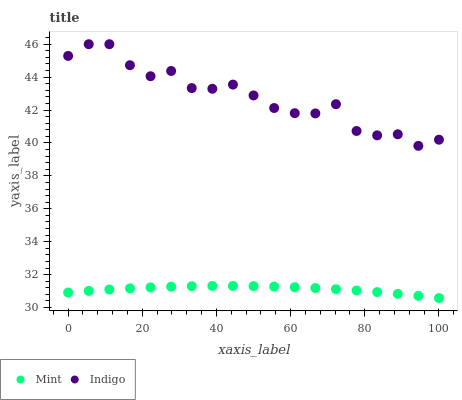Does Mint have the minimum area under the curve?
Answer yes or no. Yes. Does Indigo have the maximum area under the curve?
Answer yes or no. Yes. Does Mint have the maximum area under the curve?
Answer yes or no. No. Is Mint the smoothest?
Answer yes or no. Yes. Is Indigo the roughest?
Answer yes or no. Yes. Is Mint the roughest?
Answer yes or no. No. Does Mint have the lowest value?
Answer yes or no. Yes. Does Indigo have the highest value?
Answer yes or no. Yes. Does Mint have the highest value?
Answer yes or no. No. Is Mint less than Indigo?
Answer yes or no. Yes. Is Indigo greater than Mint?
Answer yes or no. Yes. Does Mint intersect Indigo?
Answer yes or no. No. 